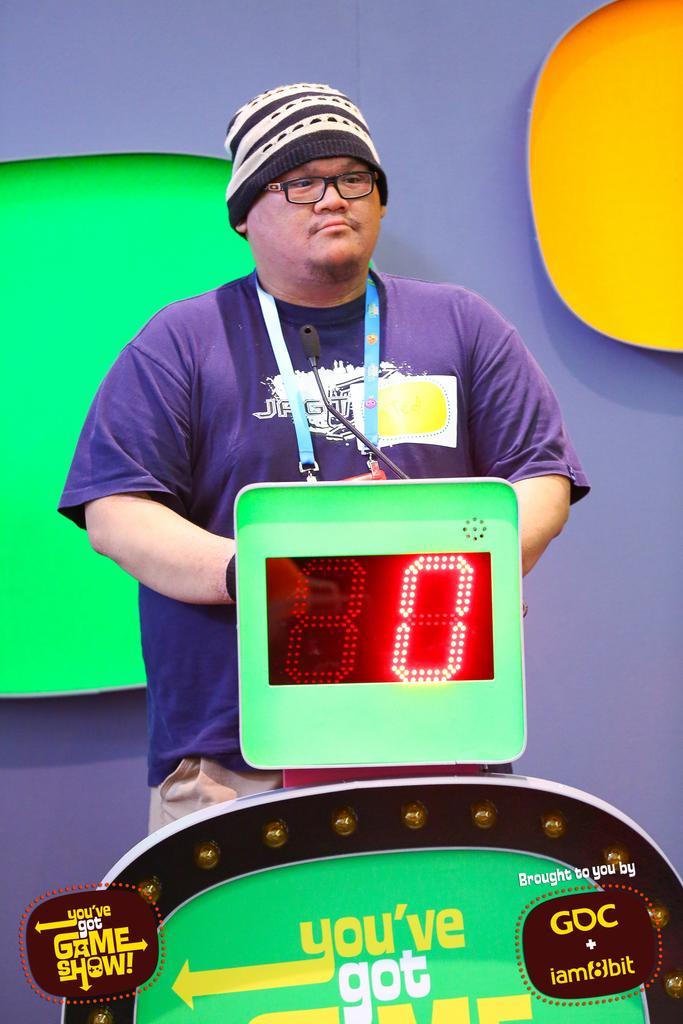Describe this image in one or two sentences. This image consists of a man wearing a blue T-shirt. He is also wearing a tag. In front of him, there is a machine to which there is a digital display. In the background, there is wall. On the left and right, we can see two colors green and yellow. 